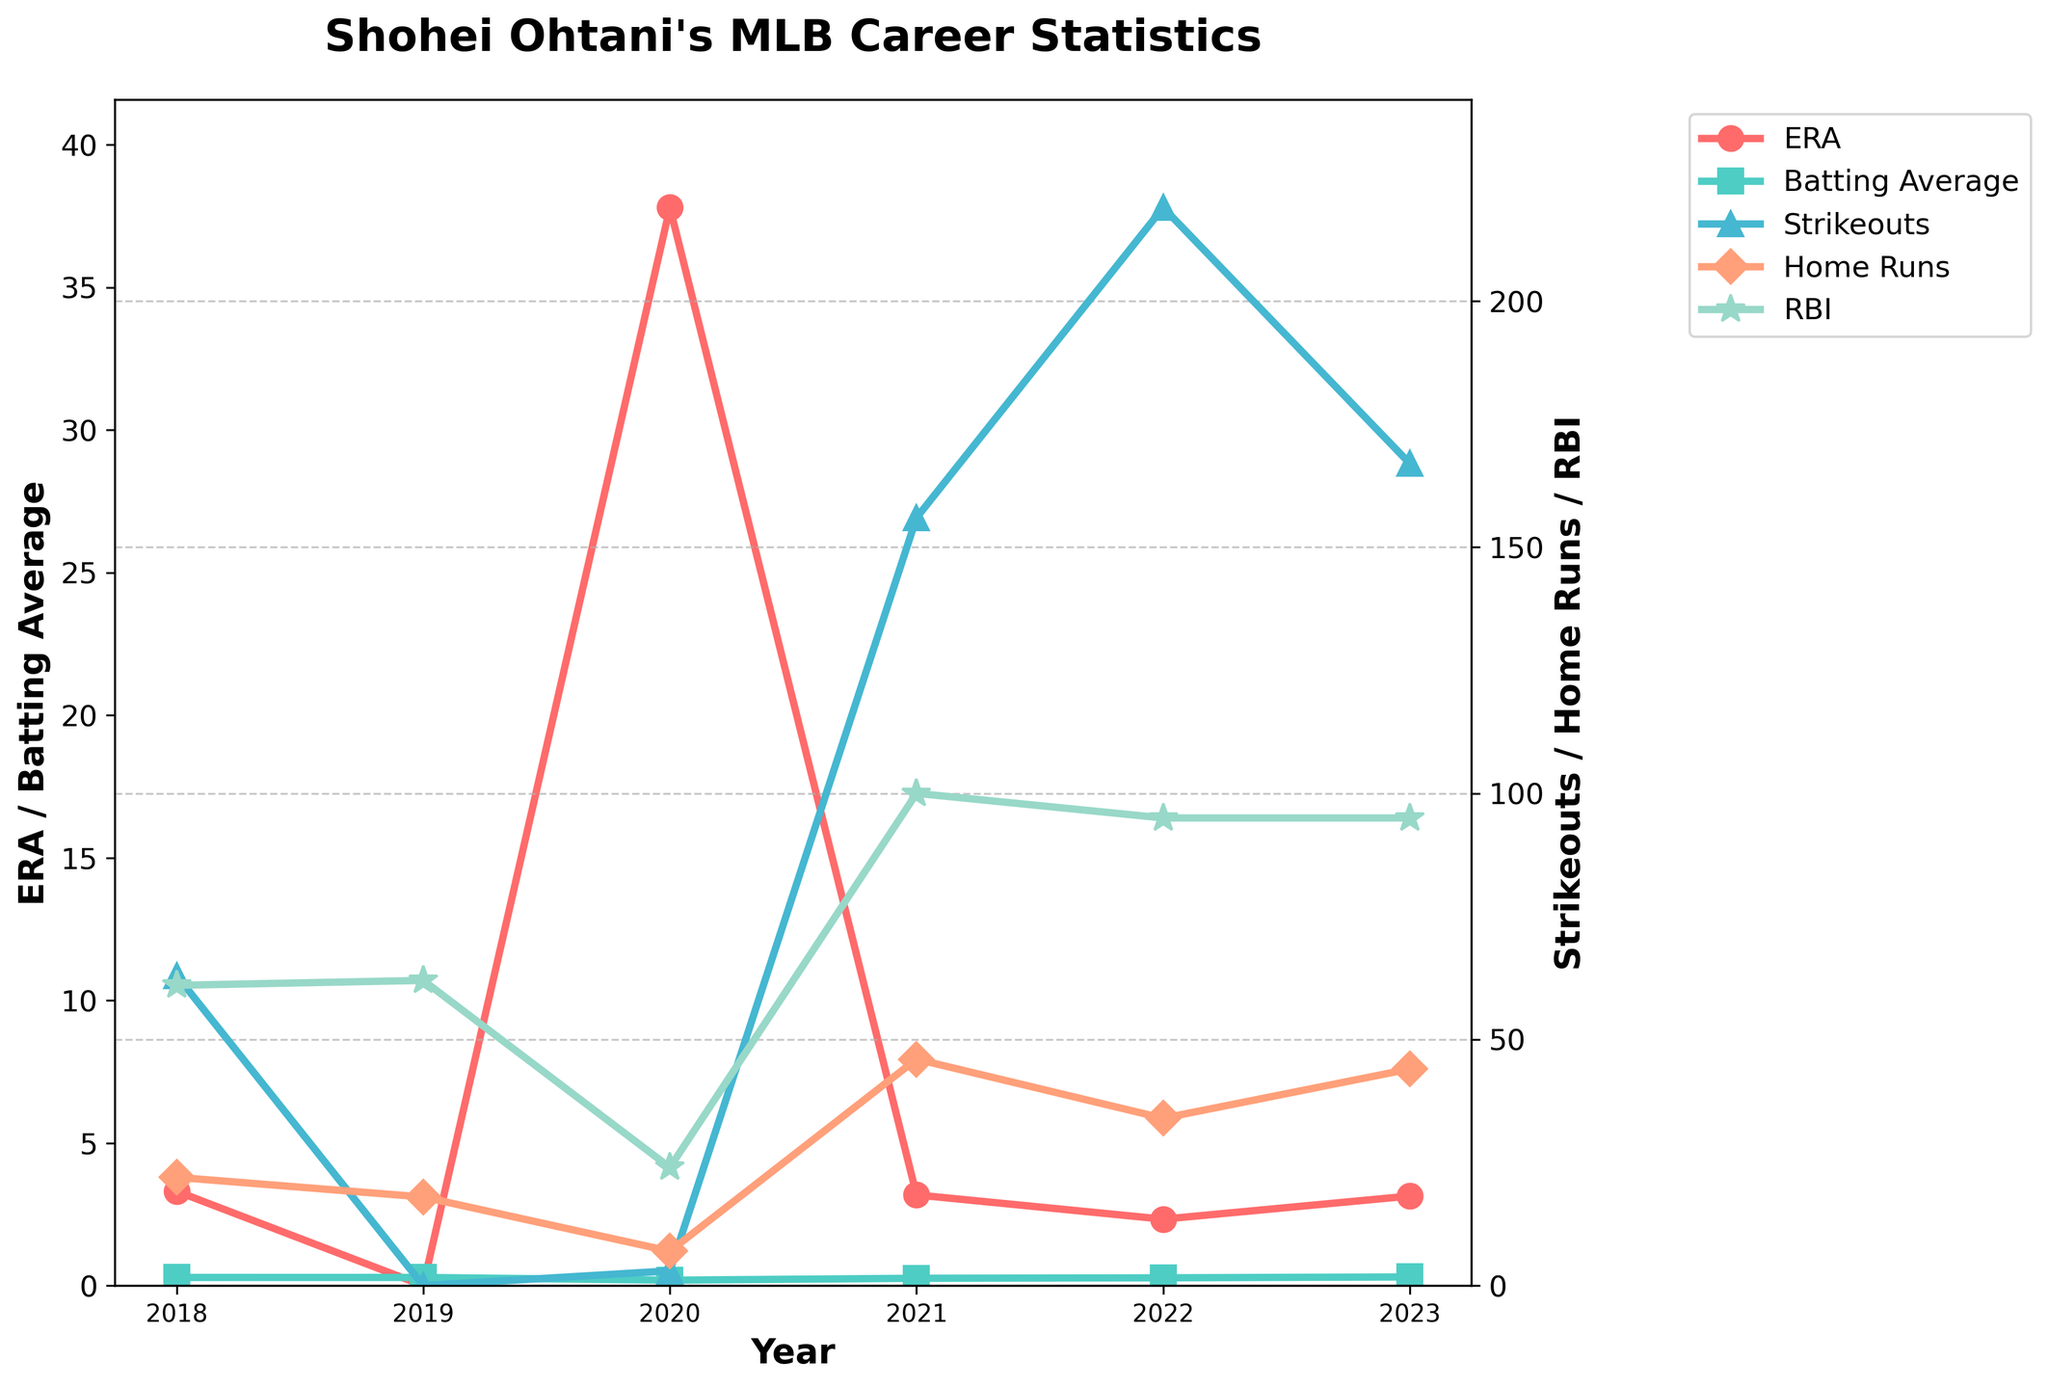Which year did Shohei Ohtani have the lowest ERA? Look at the "ERA" line and find the year where it reaches its lowest point.
Answer: 2022 What is the difference in home runs between 2021 and 2022? Look at the "Home Runs" line and find the values for 2021 and 2022. Subtract the value of 2022 from 2021. 46 - 34 = 12.
Answer: 12 Which year did Ohtani achieve the highest number of strikeouts? Look at the "Strikeouts" line and identify the year where the value is at its peak.
Answer: 2022 Did Ohtani’s batting average improve or decline from 2021 to 2023? Compare the "Batting Average" values for 2021 and 2023. 2021: .257, 2023: .304. Since .304 > .257, it improved.
Answer: Improved Which was higher in 2023, Ohtani's ERA or his Batting Average? Compare the ERA and Batting Average values for 2023. ERA: 3.14, Batting Average: .304. Since 3.14 > .304, the ERA is higher.
Answer: ERA How many strikeouts did Ohtani have in total over his career as shown? Sum the "Strikeouts" values for each year: 63 + 0 + 3 + 156 + 219 + 167 = 608.
Answer: 608 Which year did Ohtani hit the most home runs? Look at the "Home Runs" line and identify the year where the value is at its highest.
Answer: 2021 What is the trend in Ohtani's ERA from 2018 to 2022? Observe the "ERA" line from 2018 to 2022. It starts high, peaks in 2020, and then significantly declines to its lowest in 2022.
Answer: Decreasing Comparing 2018 and 2023, did Ohtani's RBI count increase or decrease? Compare the "RBI" values for 2018 and 2023. 2018: 61, 2023: 95. Since 95 > 61, it increased.
Answer: Increased 